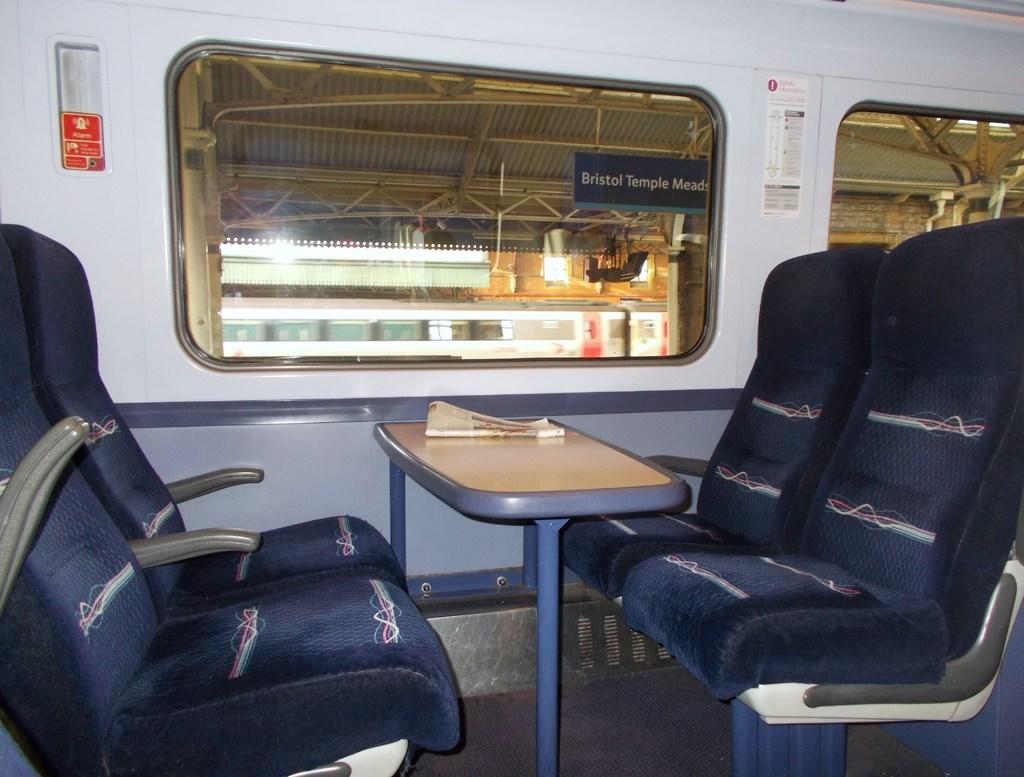What color are the seats in the image? The seats in the image are blue. What is located near the seats? There is a table in the image. What can be seen in the background of the image? There are glass windows, a train, and lights visible in the background of the image. Where is the baby sitting on a cushion in the image? There is no baby or cushion present in the image. What type of stocking is hanging near the train in the image? There is no stocking visible in the image; only the train and lights are present in the background. 